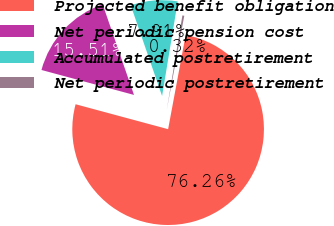Convert chart. <chart><loc_0><loc_0><loc_500><loc_500><pie_chart><fcel>Projected benefit obligation<fcel>Net periodic pension cost<fcel>Accumulated postretirement<fcel>Net periodic postretirement<nl><fcel>76.26%<fcel>15.51%<fcel>7.91%<fcel>0.32%<nl></chart> 